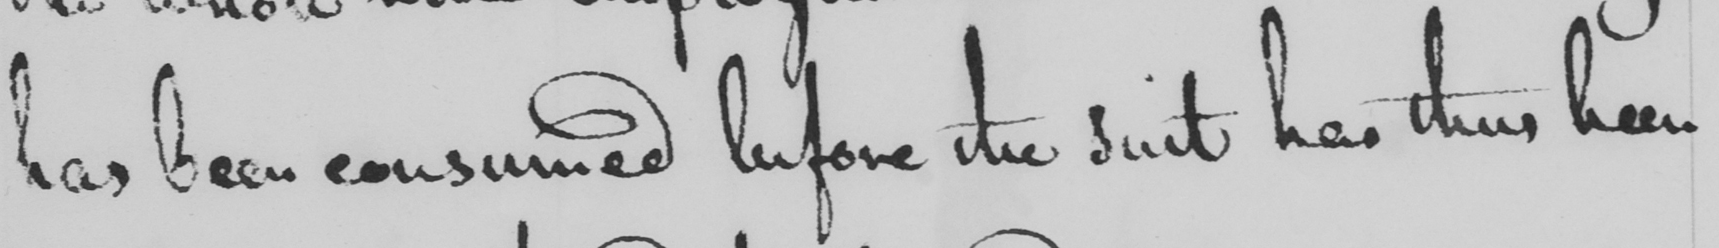What is written in this line of handwriting? has been consumed before the suit has thus been 